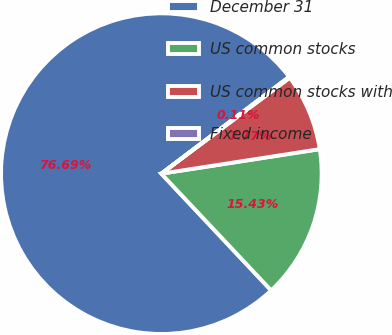<chart> <loc_0><loc_0><loc_500><loc_500><pie_chart><fcel>December 31<fcel>US common stocks<fcel>US common stocks with<fcel>Fixed income<nl><fcel>76.69%<fcel>15.43%<fcel>7.77%<fcel>0.11%<nl></chart> 